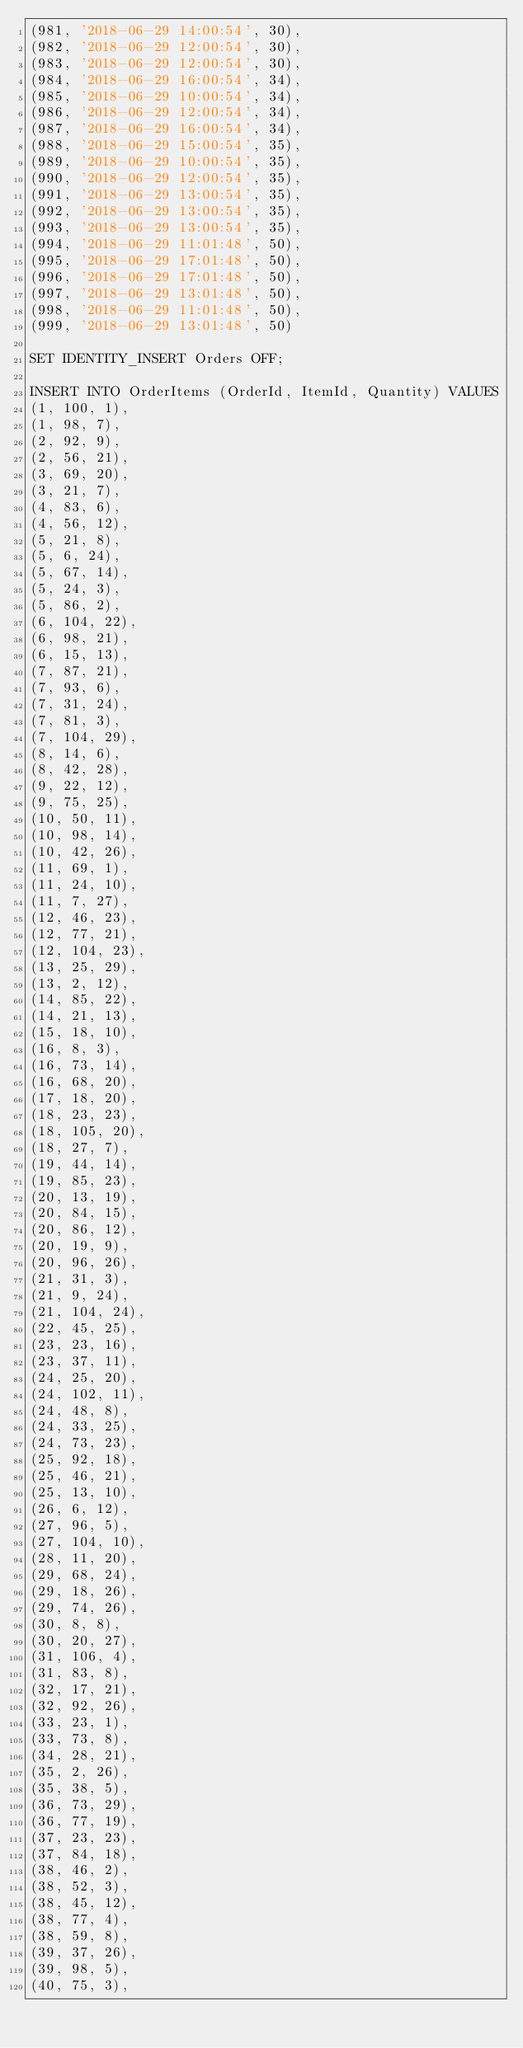Convert code to text. <code><loc_0><loc_0><loc_500><loc_500><_SQL_>(981, '2018-06-29 14:00:54', 30),
(982, '2018-06-29 12:00:54', 30),
(983, '2018-06-29 12:00:54', 30),
(984, '2018-06-29 16:00:54', 34),
(985, '2018-06-29 10:00:54', 34),
(986, '2018-06-29 12:00:54', 34),
(987, '2018-06-29 16:00:54', 34),
(988, '2018-06-29 15:00:54', 35),
(989, '2018-06-29 10:00:54', 35),
(990, '2018-06-29 12:00:54', 35),
(991, '2018-06-29 13:00:54', 35),
(992, '2018-06-29 13:00:54', 35),
(993, '2018-06-29 13:00:54', 35),
(994, '2018-06-29 11:01:48', 50),
(995, '2018-06-29 17:01:48', 50),
(996, '2018-06-29 17:01:48', 50),
(997, '2018-06-29 13:01:48', 50),
(998, '2018-06-29 11:01:48', 50),
(999, '2018-06-29 13:01:48', 50)

SET IDENTITY_INSERT Orders OFF;

INSERT INTO OrderItems (OrderId, ItemId, Quantity) VALUES
(1, 100, 1),
(1, 98, 7),
(2, 92, 9),
(2, 56, 21),
(3, 69, 20),
(3, 21, 7),
(4, 83, 6),
(4, 56, 12),
(5, 21, 8),
(5, 6, 24),
(5, 67, 14),
(5, 24, 3),
(5, 86, 2),
(6, 104, 22),
(6, 98, 21),
(6, 15, 13),
(7, 87, 21),
(7, 93, 6),
(7, 31, 24),
(7, 81, 3),
(7, 104, 29),
(8, 14, 6),
(8, 42, 28),
(9, 22, 12),
(9, 75, 25),
(10, 50, 11),
(10, 98, 14),
(10, 42, 26),
(11, 69, 1),
(11, 24, 10),
(11, 7, 27),
(12, 46, 23),
(12, 77, 21),
(12, 104, 23),
(13, 25, 29),
(13, 2, 12),
(14, 85, 22),
(14, 21, 13),
(15, 18, 10),
(16, 8, 3),
(16, 73, 14),
(16, 68, 20),
(17, 18, 20),
(18, 23, 23),
(18, 105, 20),
(18, 27, 7),
(19, 44, 14),
(19, 85, 23),
(20, 13, 19),
(20, 84, 15),
(20, 86, 12),
(20, 19, 9),
(20, 96, 26),
(21, 31, 3),
(21, 9, 24),
(21, 104, 24),
(22, 45, 25),
(23, 23, 16),
(23, 37, 11),
(24, 25, 20),
(24, 102, 11),
(24, 48, 8),
(24, 33, 25),
(24, 73, 23),
(25, 92, 18),
(25, 46, 21),
(25, 13, 10),
(26, 6, 12),
(27, 96, 5),
(27, 104, 10),
(28, 11, 20),
(29, 68, 24),
(29, 18, 26),
(29, 74, 26),
(30, 8, 8),
(30, 20, 27),
(31, 106, 4),
(31, 83, 8),
(32, 17, 21),
(32, 92, 26),
(33, 23, 1),
(33, 73, 8),
(34, 28, 21),
(35, 2, 26),
(35, 38, 5),
(36, 73, 29),
(36, 77, 19),
(37, 23, 23),
(37, 84, 18),
(38, 46, 2),
(38, 52, 3),
(38, 45, 12),
(38, 77, 4),
(38, 59, 8),
(39, 37, 26),
(39, 98, 5),
(40, 75, 3),</code> 